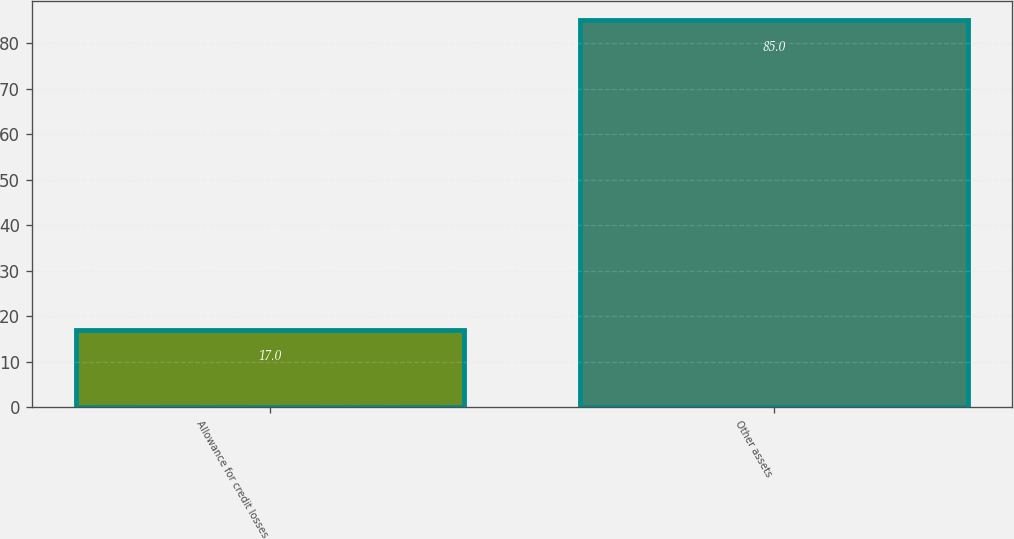Convert chart to OTSL. <chart><loc_0><loc_0><loc_500><loc_500><bar_chart><fcel>Allowance for credit losses<fcel>Other assets<nl><fcel>17<fcel>85<nl></chart> 